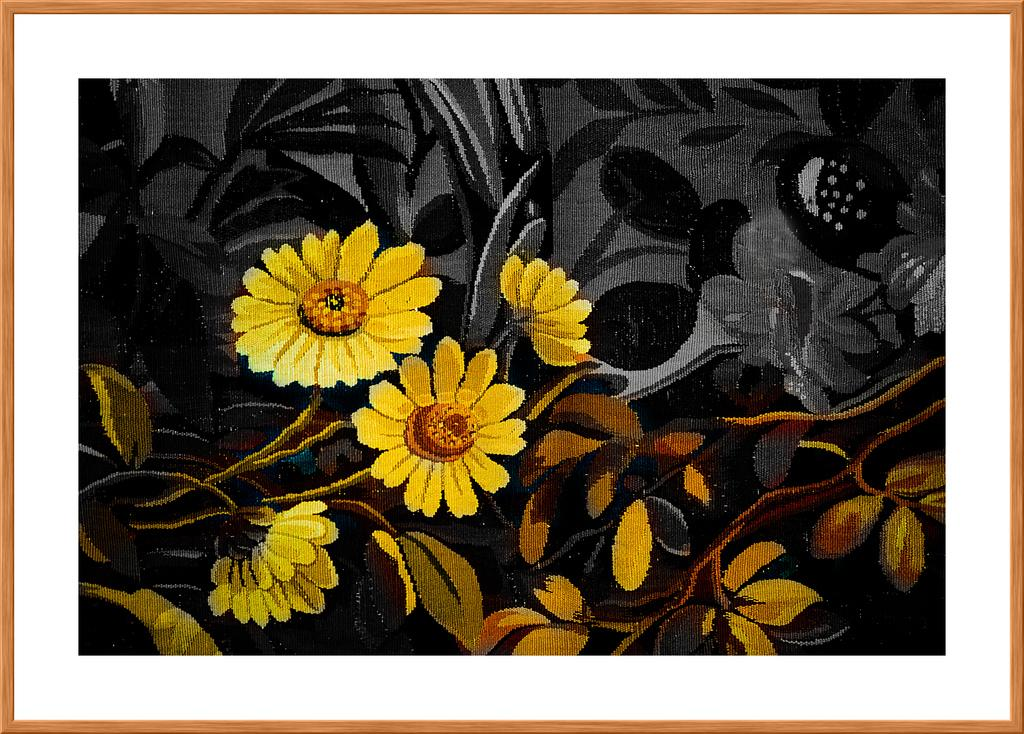What is the main object in the image? There is a frame in the image. What is inside the frame? The frame contains a painting. What is the subject of the painting? The painting depicts yellow color flowers. Are the flowers part of a larger plant? Yes, the flowers are on a plant. What time does the hen appear in the image? There is no hen present in the image. Can you tell me how many times the person in the image sneezes? There is no person present in the image, and therefore no sneezing can be observed. 